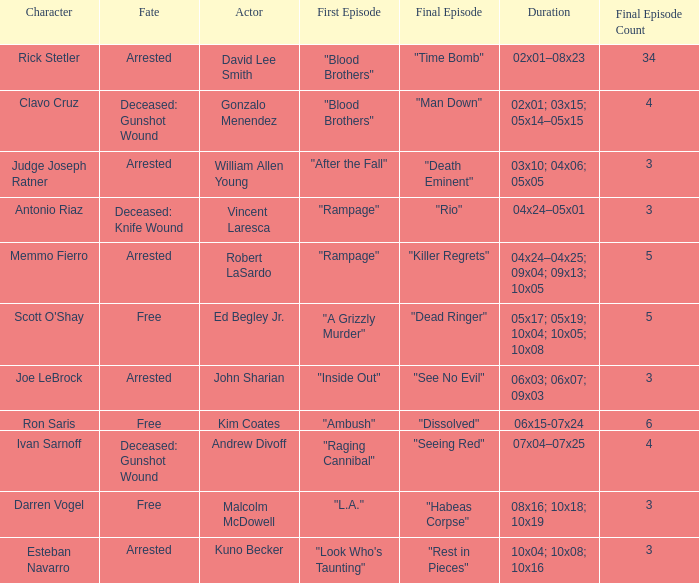What are all the actor where first episode is "ambush" Kim Coates. 